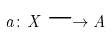<formula> <loc_0><loc_0><loc_500><loc_500>a \colon X \longrightarrow A</formula> 